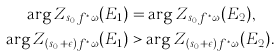<formula> <loc_0><loc_0><loc_500><loc_500>\arg Z _ { s _ { 0 } f ^ { \ast } \omega } ( E _ { 1 } ) & = \arg Z _ { s _ { 0 } f ^ { \ast } \omega } ( E _ { 2 } ) , \\ \arg Z _ { ( s _ { 0 } + \epsilon ) f ^ { \ast } \omega } ( E _ { 1 } ) & > \arg Z _ { ( s _ { 0 } + \epsilon ) f ^ { \ast } \omega } ( E _ { 2 } ) .</formula> 